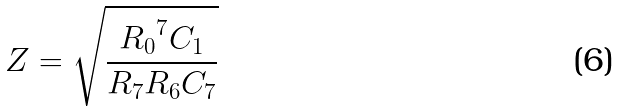<formula> <loc_0><loc_0><loc_500><loc_500>Z = \sqrt { \frac { { R _ { 0 } } ^ { 7 } C _ { 1 } } { R _ { 7 } R _ { 6 } C _ { 7 } } }</formula> 